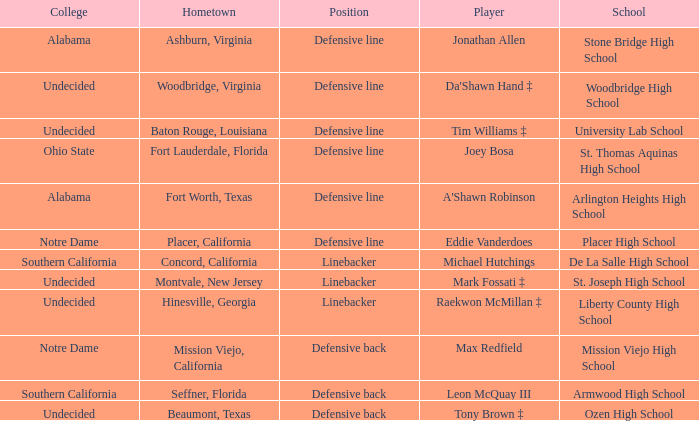I'm looking to parse the entire table for insights. Could you assist me with that? {'header': ['College', 'Hometown', 'Position', 'Player', 'School'], 'rows': [['Alabama', 'Ashburn, Virginia', 'Defensive line', 'Jonathan Allen', 'Stone Bridge High School'], ['Undecided', 'Woodbridge, Virginia', 'Defensive line', "Da'Shawn Hand ‡", 'Woodbridge High School'], ['Undecided', 'Baton Rouge, Louisiana', 'Defensive line', 'Tim Williams ‡', 'University Lab School'], ['Ohio State', 'Fort Lauderdale, Florida', 'Defensive line', 'Joey Bosa', 'St. Thomas Aquinas High School'], ['Alabama', 'Fort Worth, Texas', 'Defensive line', "A'Shawn Robinson", 'Arlington Heights High School'], ['Notre Dame', 'Placer, California', 'Defensive line', 'Eddie Vanderdoes', 'Placer High School'], ['Southern California', 'Concord, California', 'Linebacker', 'Michael Hutchings', 'De La Salle High School'], ['Undecided', 'Montvale, New Jersey', 'Linebacker', 'Mark Fossati ‡', 'St. Joseph High School'], ['Undecided', 'Hinesville, Georgia', 'Linebacker', 'Raekwon McMillan ‡', 'Liberty County High School'], ['Notre Dame', 'Mission Viejo, California', 'Defensive back', 'Max Redfield', 'Mission Viejo High School'], ['Southern California', 'Seffner, Florida', 'Defensive back', 'Leon McQuay III', 'Armwood High School'], ['Undecided', 'Beaumont, Texas', 'Defensive back', 'Tony Brown ‡', 'Ozen High School']]} What college did the player from Liberty County High School attend? Undecided. 